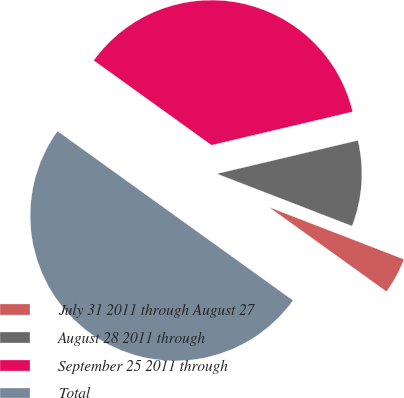<chart> <loc_0><loc_0><loc_500><loc_500><pie_chart><fcel>July 31 2011 through August 27<fcel>August 28 2011 through<fcel>September 25 2011 through<fcel>Total<nl><fcel>4.05%<fcel>9.57%<fcel>36.38%<fcel>50.0%<nl></chart> 